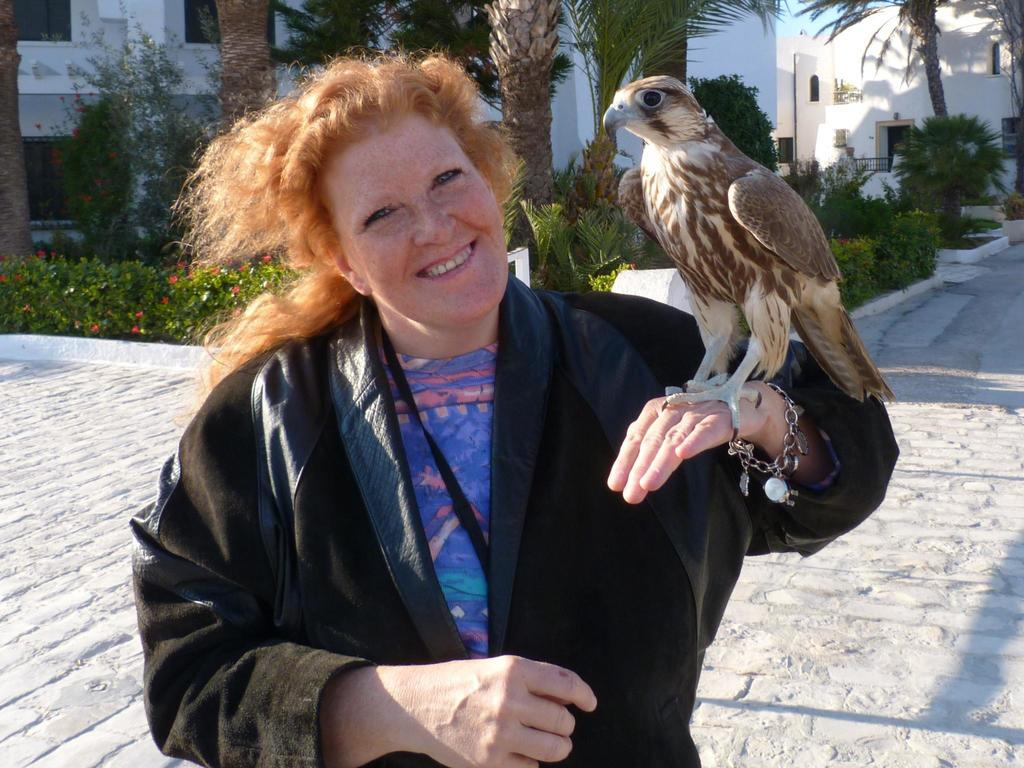Who is present in the image? There is a woman in the image. What is the woman holding in the image? There is an eagle on the woman's hand. What can be seen in the background of the image? Trees and buildings are visible in the background of the image. What is located in the middle of the image? There are plants in the middle of the image. What type of popcorn is being served to the giants in the image? There are no giants or popcorn present in the image. 